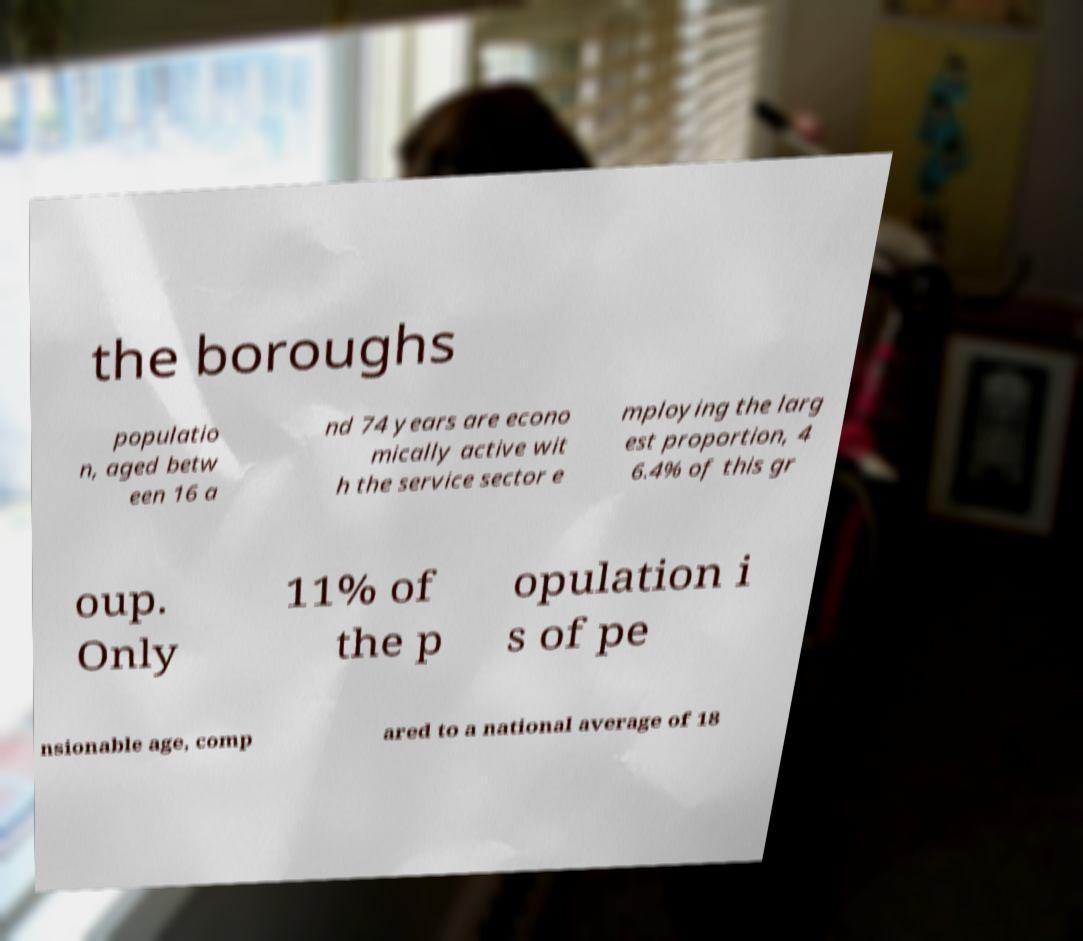Can you read and provide the text displayed in the image?This photo seems to have some interesting text. Can you extract and type it out for me? the boroughs populatio n, aged betw een 16 a nd 74 years are econo mically active wit h the service sector e mploying the larg est proportion, 4 6.4% of this gr oup. Only 11% of the p opulation i s of pe nsionable age, comp ared to a national average of 18 